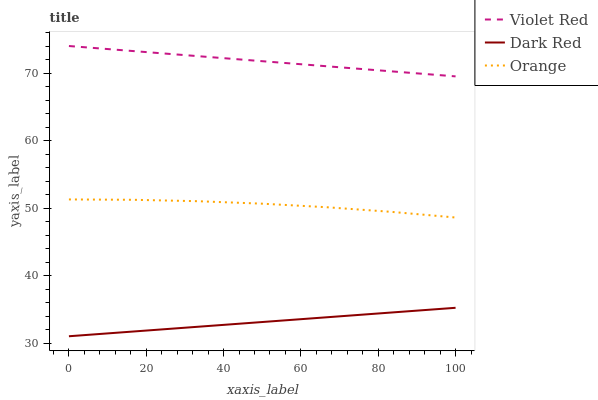Does Dark Red have the minimum area under the curve?
Answer yes or no. Yes. Does Violet Red have the maximum area under the curve?
Answer yes or no. Yes. Does Violet Red have the minimum area under the curve?
Answer yes or no. No. Does Dark Red have the maximum area under the curve?
Answer yes or no. No. Is Dark Red the smoothest?
Answer yes or no. Yes. Is Orange the roughest?
Answer yes or no. Yes. Is Violet Red the smoothest?
Answer yes or no. No. Is Violet Red the roughest?
Answer yes or no. No. Does Dark Red have the lowest value?
Answer yes or no. Yes. Does Violet Red have the lowest value?
Answer yes or no. No. Does Violet Red have the highest value?
Answer yes or no. Yes. Does Dark Red have the highest value?
Answer yes or no. No. Is Orange less than Violet Red?
Answer yes or no. Yes. Is Orange greater than Dark Red?
Answer yes or no. Yes. Does Orange intersect Violet Red?
Answer yes or no. No. 